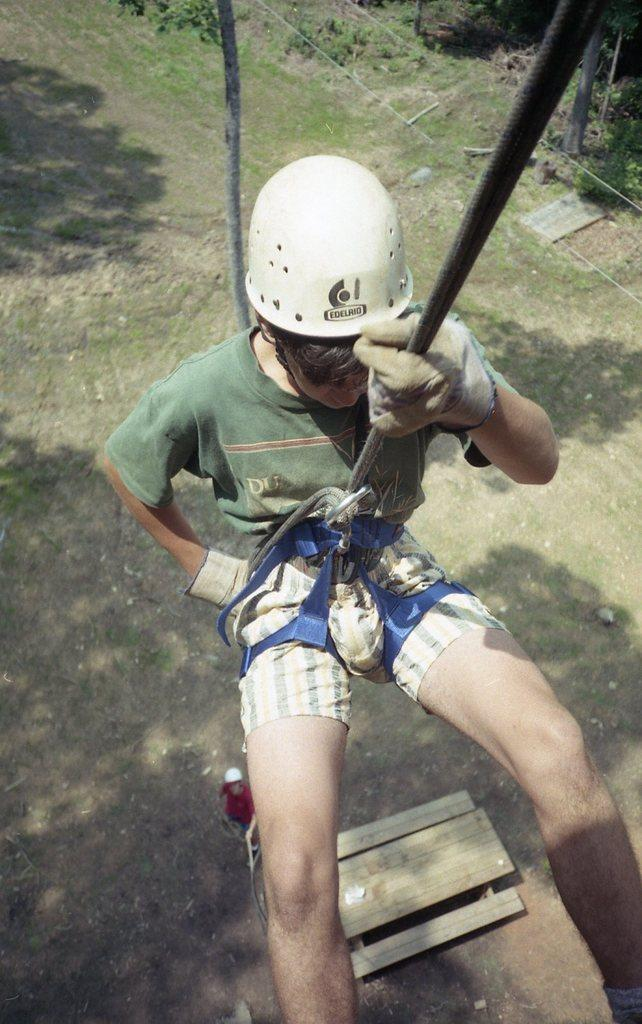What activity is the person in the image engaged in? The person in the image is abseiling. What type of natural environment is depicted in the image? There are trees and plants in the image, suggesting a natural setting. What else can be seen on the ground in the image? There are other objects on the ground in the image. How many secretaries are visible in the image? There are no secretaries present in the image. What type of net is being used by the children in the image? There are no children or nets present in the image. 